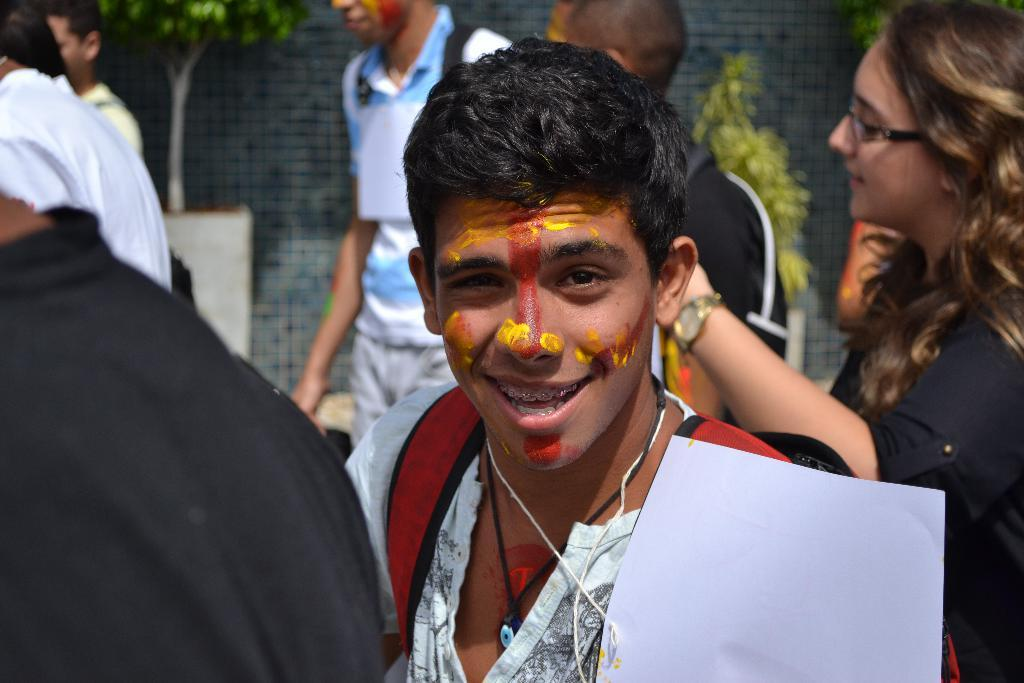Who or what can be seen in the image? There are people in the image. What is located at the bottom side of the image? There is an object in the bottom side of the image. What can be seen in the background of the image? There is a wall and plants in pots in the background of the image. What type of organization is depicted in the image? There is no organization depicted in the image; it features people, an object, a wall, and plants in pots. How many plants are shown changing colors in the image? There are no plants shown changing colors in the image; the plants are in pots and appear to be stationary. 